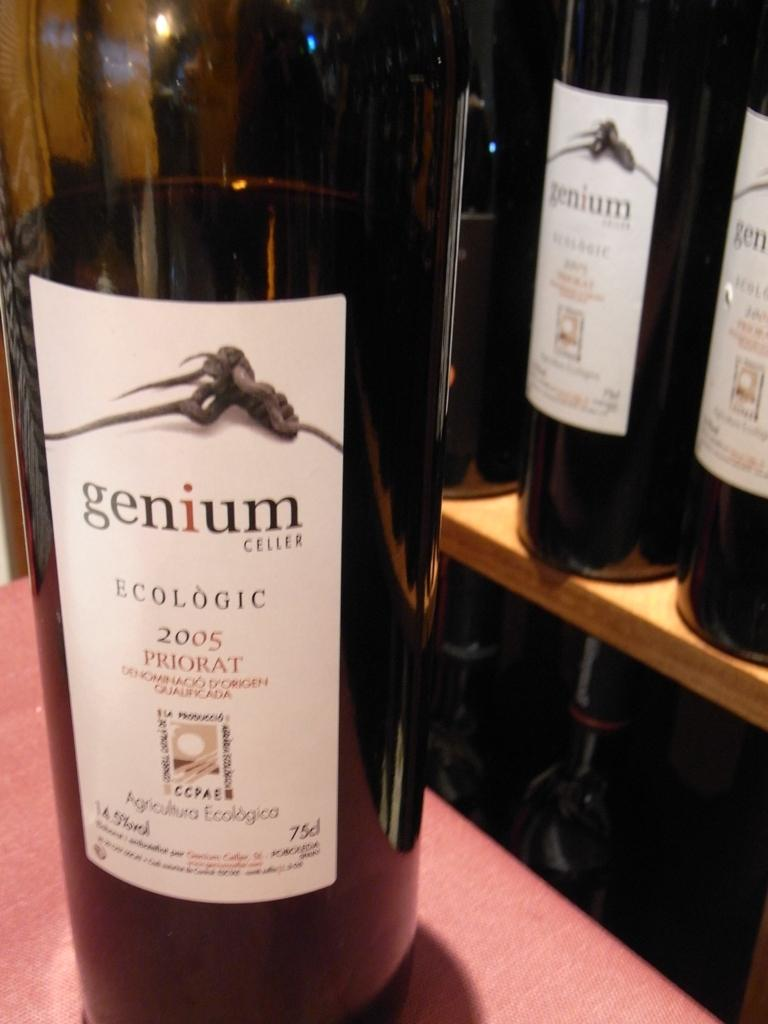Provide a one-sentence caption for the provided image. A bottle of genium Celler ecologic wine on a table. 